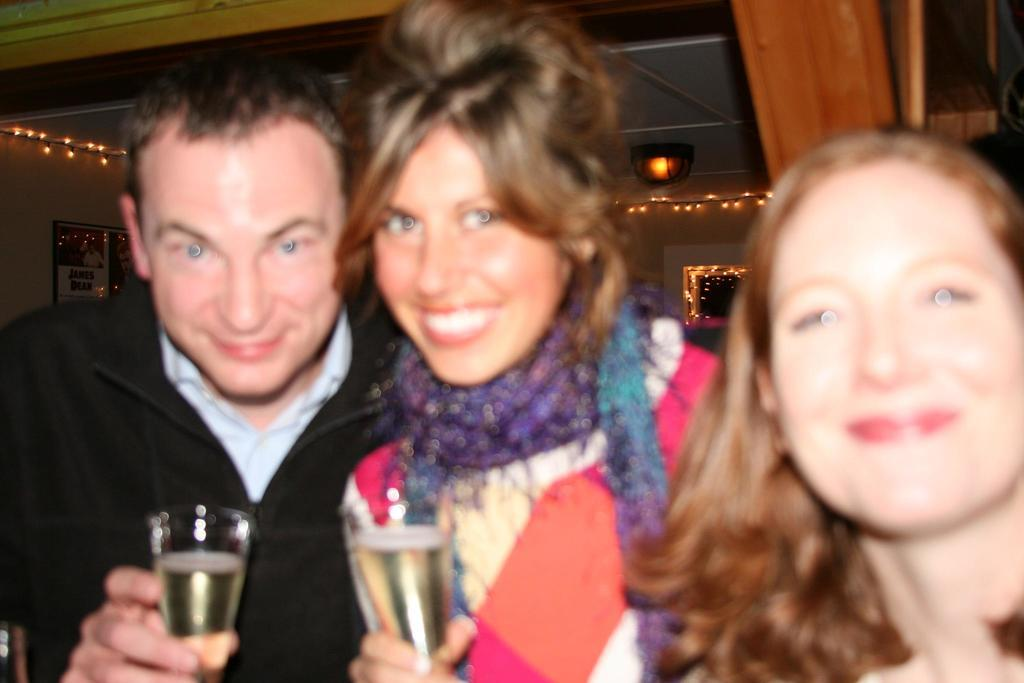How many people are in the image? There are three persons in the image. What are the persons doing in the image? The persons are standing and smiling. What are the persons holding in the image? The persons are holding glasses. What can be seen in the background of the image? There is a wall in the background of the image. What type of linen is being used by the beggar in the image? There is no beggar present in the image, and therefore no linen can be associated with a beggar. What color is the sweater worn by the person on the right in the image? The provided facts do not mention any clothing details, such as the color of a sweater, so we cannot answer this question. 